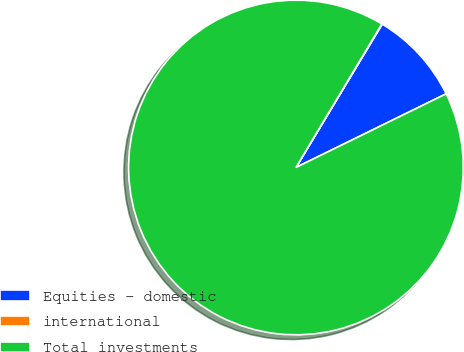Convert chart. <chart><loc_0><loc_0><loc_500><loc_500><pie_chart><fcel>Equities - domestic<fcel>international<fcel>Total investments<nl><fcel>9.12%<fcel>0.04%<fcel>90.84%<nl></chart> 